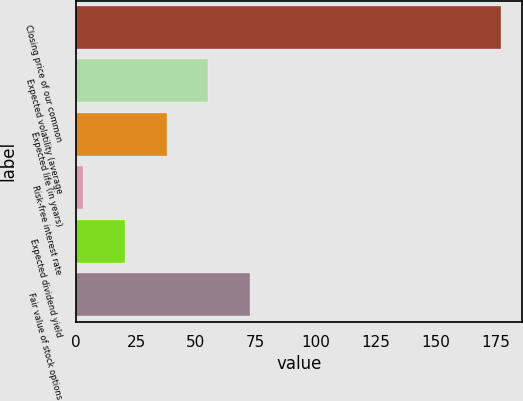Convert chart. <chart><loc_0><loc_0><loc_500><loc_500><bar_chart><fcel>Closing price of our common<fcel>Expected volatility (average<fcel>Expected life (in years)<fcel>Risk-free interest rate<fcel>Expected dividend yield<fcel>Fair value of stock options<nl><fcel>177.46<fcel>55.21<fcel>37.74<fcel>2.8<fcel>20.27<fcel>72.68<nl></chart> 